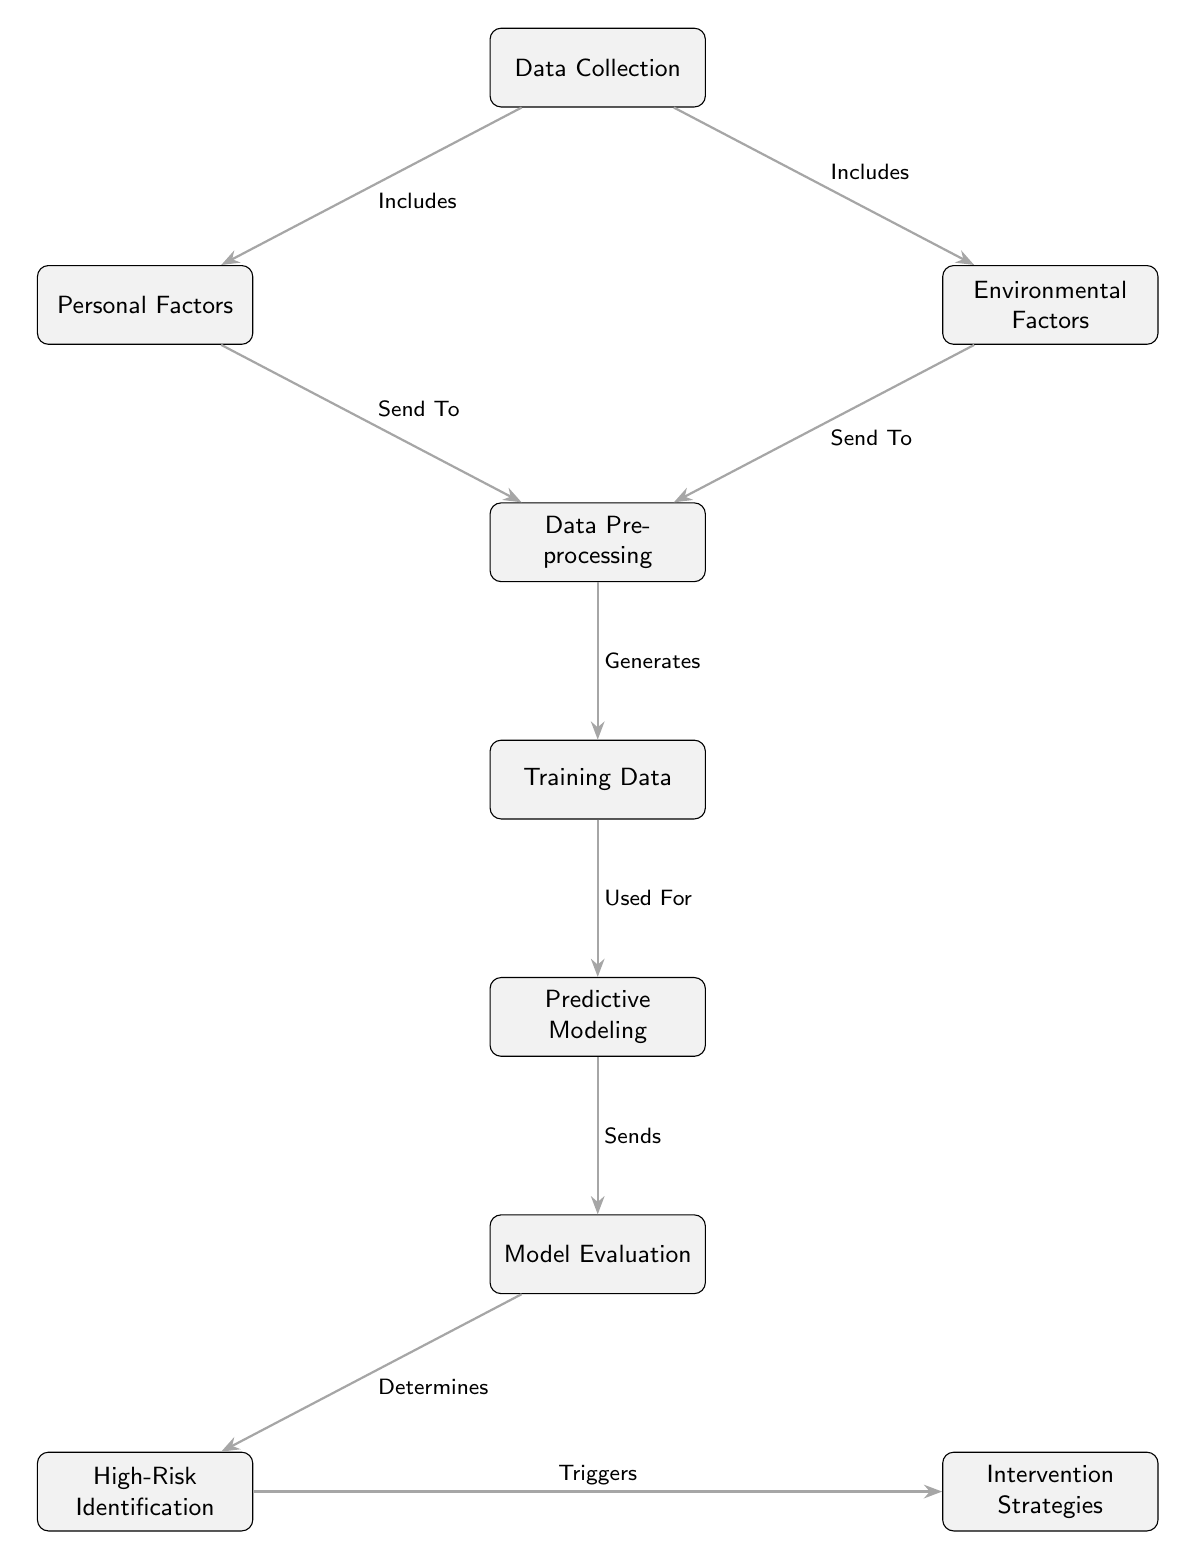What are the two main factors considered in the diagram? The two main factors are Personal Factors and Environmental Factors, which are both branches below the Data Collection node.
Answer: Personal Factors and Environmental Factors How many nodes are in the diagram? By counting all distinct points in the diagram, we find a total of eight nodes, including Data Collection and the others.
Answer: Eight What does Data Preprocessing generate? Data Preprocessing generates Training Data as indicated by the arrow connecting the two nodes.
Answer: Training Data Which node identifies high-risk periods? The High-Risk Identification node, which is directly connected to the Model Evaluation node, is responsible for identifying high-risk periods.
Answer: High-Risk Identification What is the direct output of Model Evaluation? The direct output of Model Evaluation is High-Risk Identification, as it determines this output according to the flow depicted in the diagram.
Answer: High-Risk Identification What directly triggers Intervention Strategies? Intervention Strategies are triggered by the High-Risk Identification node, which shows a direct connection and flow to it.
Answer: High-Risk Identification Which steps precede Predictive Modeling? The steps preceding Predictive Modeling are Data Preprocessing and Training Data, as these are necessary inputs before moving to the predictive modeling stage.
Answer: Data Preprocessing and Training Data What relationship exists between Environmental Factors and Data Preprocessing? Environmental Factors have a relationship defined as "Send To," indicating that they are transferred to Data Preprocessing for further analysis.
Answer: Send To What is the flow direction from Training Data to Predictive Modeling? The flow direction is clearly indicated as "Used For," meaning that Training Data provides the necessary input for Predictive Modeling.
Answer: Used For 